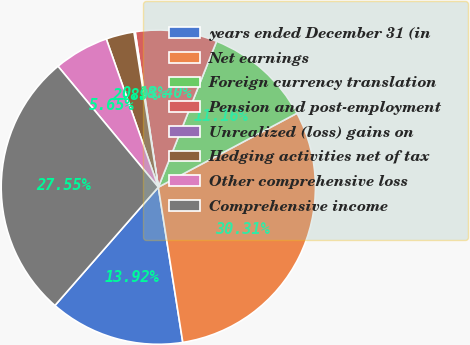Convert chart to OTSL. <chart><loc_0><loc_0><loc_500><loc_500><pie_chart><fcel>years ended December 31 (in<fcel>Net earnings<fcel>Foreign currency translation<fcel>Pension and post-employment<fcel>Unrealized (loss) gains on<fcel>Hedging activities net of tax<fcel>Other comprehensive loss<fcel>Comprehensive income<nl><fcel>13.92%<fcel>30.31%<fcel>11.16%<fcel>8.4%<fcel>0.13%<fcel>2.89%<fcel>5.65%<fcel>27.55%<nl></chart> 